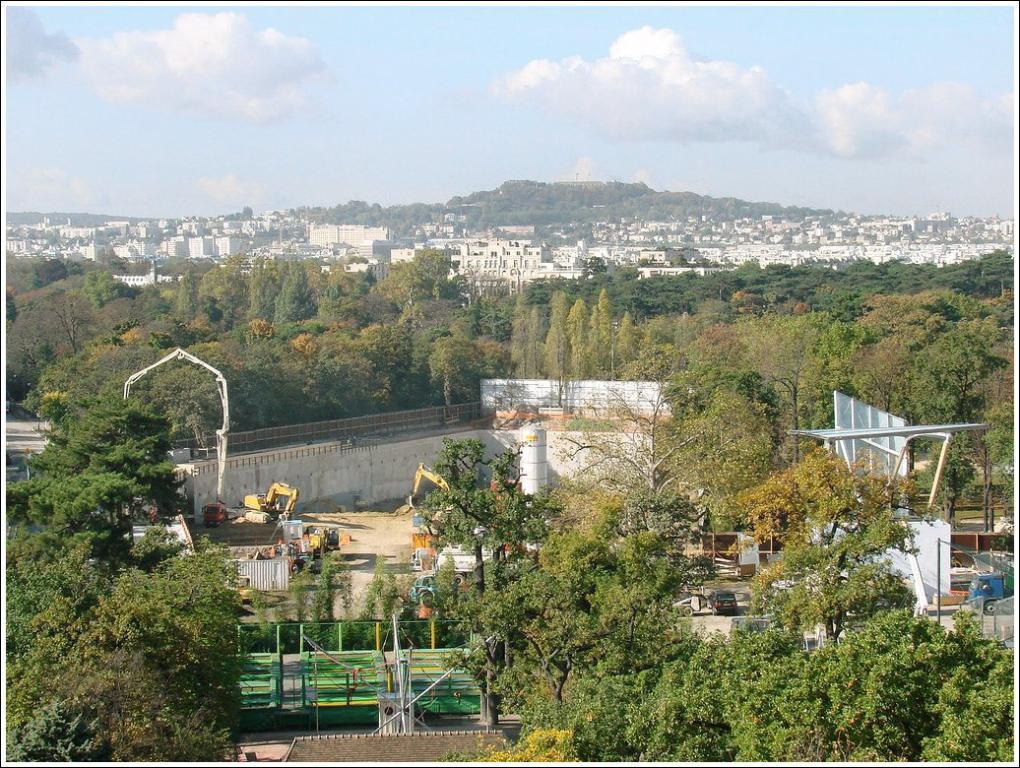What can be seen in the sky in the background of the image? There are clouds in the sky in the background of the image. What type of vegetation is present in the image? There is a thicket and trees in the image. What type of vehicles can be seen in the image? There are vehicles in the image. What type of construction equipment is present in the image? There are excavators in the image. What type of structures are present in the image? There are poles and a concrete tower in the image. What type of safety feature is present in the image? There is railing in the image. What type of objects are present in the image? There are objects in the image, but their specific nature is not mentioned in the facts. How much bait is needed to catch a fish in the image? There is no mention of fish or bait in the image. 